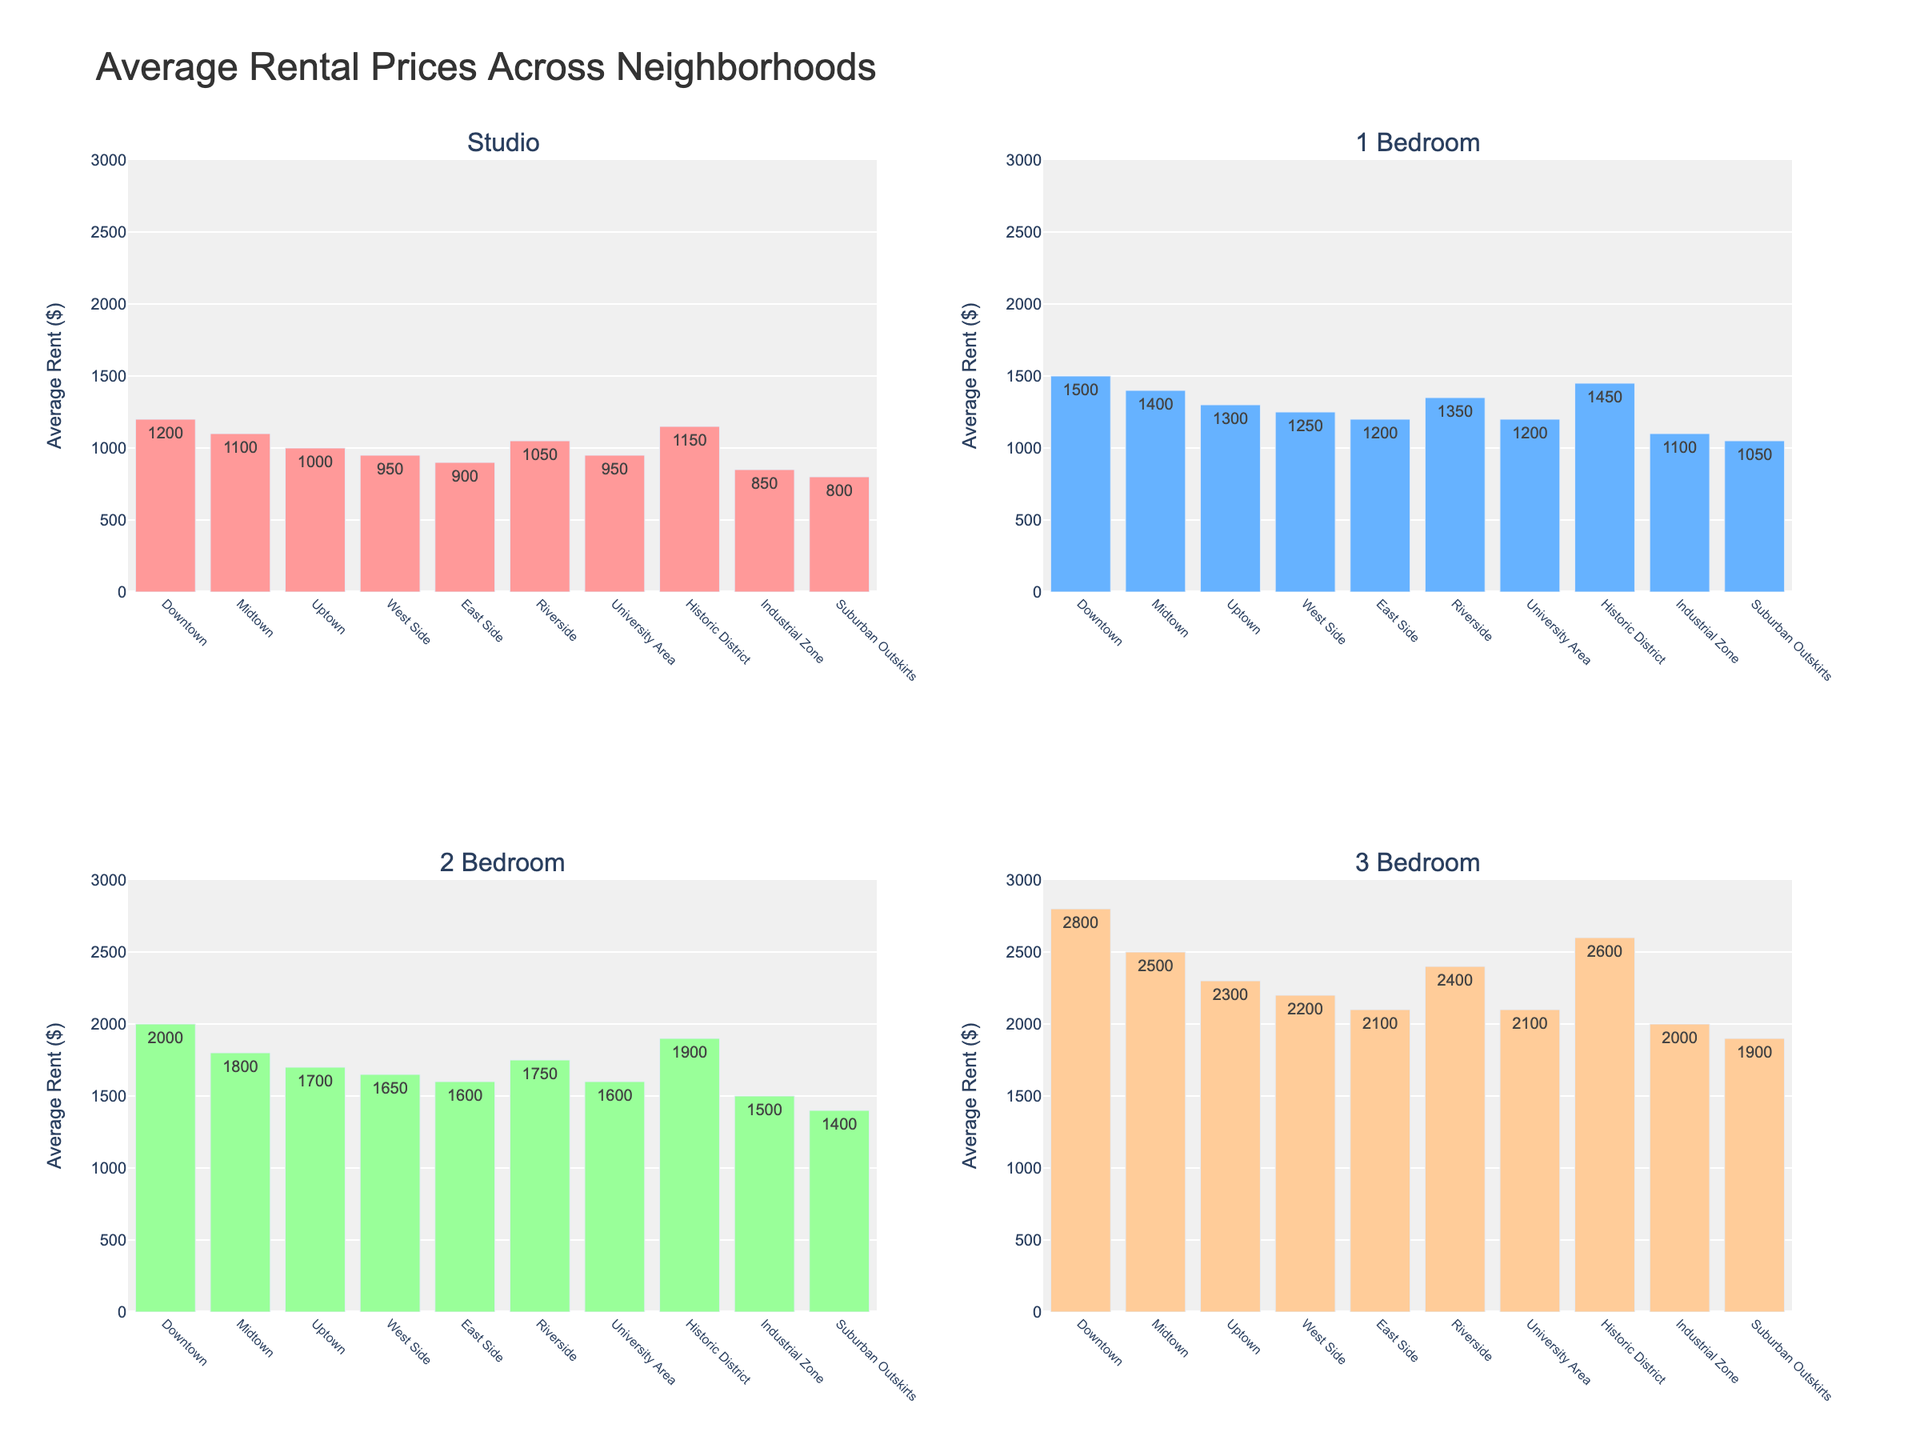What is the most expensive average rent for a 3 Bedroom apartment? To find the most expensive average rent for a 3 Bedroom apartment, look at the bars in the subplot titled "3 Bedroom". The tallest bar will indicate the highest rent. In this case, the tallest bar corresponds to Downtown with a rent of $2800.
Answer: $2800 Which neighborhood has the lowest average rental price for Studio apartments? To determine which neighborhood has the lowest average rent for Studio apartments, examine the subplot titled "Studio". The shortest bar corresponds to Suburban Outskirts with a rent of $800.
Answer: Suburban Outskirts Compare the average rental prices for 1 Bedroom apartments in Downtown and Midtown. Which is higher, and by how much? In the subplot titled "1 Bedroom", compare the height of the bars for Downtown and Midtown. Downtown has a rental price of $1500, and Midtown has a rental price of $1400. The difference is $1500 - $1400 = $100.
Answer: Downtown, $100 What is the combined average rental price for a 2 Bedroom apartment in Riverside and Historic District? To find the combined average rent for a 2 Bedroom apartment in Riverside and Historic District, look at their respective bars in the "2 Bedroom" subplot. Riverside has a rent of $1750 while Historic District has $1900. The combined rent is $1750 + $1900 = $3650.
Answer: $3650 Which apartment size in Industrial Zone has the largest difference in average rental price compared to the same size in Midtown? First, find the differences for each apartment size between Industrial Zone and Midtown. For Studio: $1100 - $850 = $250, for 1 Bedroom: $1400 - $1100 = $300, for 2 Bedroom: $1800 - $1500 = $300, for 3 Bedroom: $2500 - $2000 = $500. The largest difference is for 3 Bedroom apartments, with a difference of $500.
Answer: 3 Bedroom, $500 